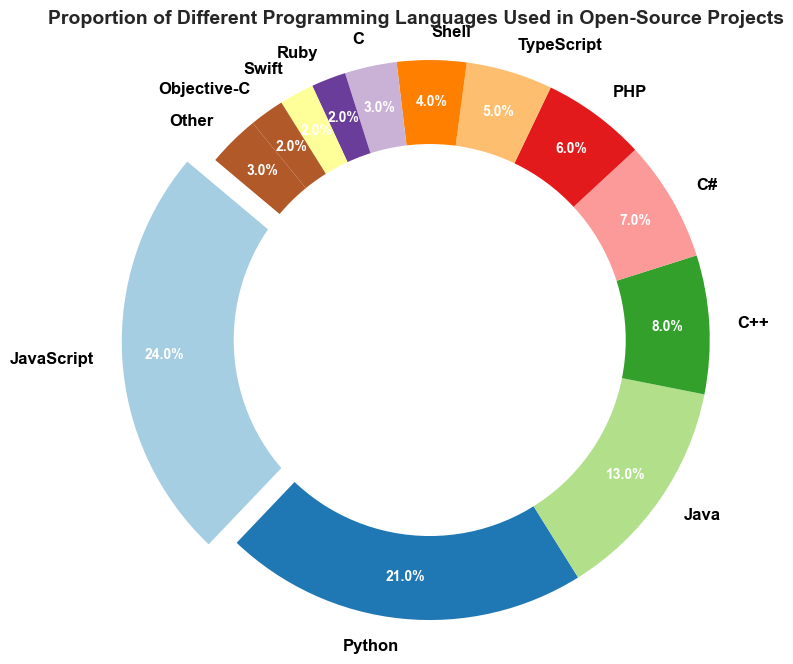What is the most commonly used programming language in open-source projects? The pie chart highlights the most common programming language by separating its slice with an "explode" effect. The largest slice, which is exploded, indicates the most commonly used language.
Answer: JavaScript Which language is used more frequently, Python or Java? By comparing the size of the slices, Python has a 21% share while Java has a 13% share, indicating that Python is used more frequently.
Answer: Python What is the combined proportion of C++, C#, and PHP usage in open-source projects? The slices for C++, C#, and PHP represent 8%, 7%, and 6% respectively. Adding these proportions together, 8+7+6 = 21.
Answer: 21% How does the usage of Swift compare to Objective-C? Both Swift and Objective-C have equal-sized slices in the pie chart, each representing 2%. Thus, they are used with the same frequency.
Answer: Equal Are more than half of the open-source projects using JavaScript and Python combined? The slices for JavaScript and Python show 24% and 21%, respectively. Adding these proportions together, 24+21 = 45%, which is less than half.
Answer: No What is the difference in the proportion of usage between TypeScript and Shell? The pie chart shows TypeScript with a 5% share and Shell with a 4% share. The difference is 5 - 4 = 1.
Answer: 1% Which language in the chart has the smallest proportion, and what is it? Several languages have small slices, but Ruby, Swift, and Objective-C each have 2%. Among these, any one can be cited since they share the smallest proportion.
Answer: Ruby What is the summed proportion of all the languages that have a share of 5% or less? Summing the slices for TypeScript (5%), Shell (4%), C (3%), Ruby (2%), Swift (2%), Objective-C (2%), and Other (3%), we get 5 + 4 + 3 + 2 + 2 + 2 + 3 = 21.
Answer: 21% Visually, which is the third largest slice in the pie chart? The pie chart shows the third largest slice represents Java with a 13% share, after JavaScript and Python.
Answer: Java If you only consider the languages with more than 5% usage, what is the average proportion? Languages with more than 5% usage are JavaScript (24%), Python (21%), Java (13%), C++ (8%), and C# (7%). The sum is 24 + 21 + 13 + 8 + 7 = 73, and there are 5 languages, so the average proportion is 73 / 5 = 14.6.
Answer: 14.6% 